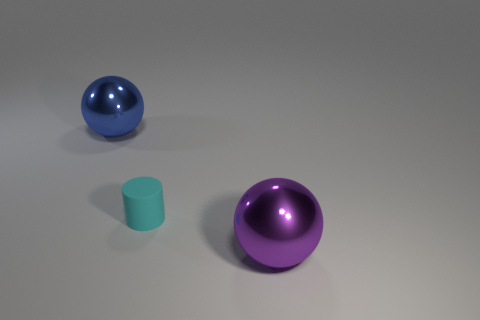Is there anything else that is the same material as the small cylinder?
Provide a succinct answer. No. Are there any other things that are the same size as the cyan rubber thing?
Provide a succinct answer. No. What number of other things are there of the same color as the tiny rubber cylinder?
Your answer should be very brief. 0. There is a metallic sphere on the left side of the purple sphere; is its size the same as the purple shiny sphere?
Offer a very short reply. Yes. There is a big purple ball to the right of the cyan thing; is there a small matte object that is right of it?
Make the answer very short. No. What is the material of the large purple thing?
Your response must be concise. Metal. There is a purple metallic sphere; are there any purple balls left of it?
Your answer should be compact. No. What size is the blue shiny object that is the same shape as the purple object?
Your answer should be compact. Large. Is the number of cyan cylinders that are on the right side of the small cyan matte cylinder the same as the number of big purple metal balls on the left side of the blue thing?
Give a very brief answer. Yes. What number of green blocks are there?
Provide a succinct answer. 0. 